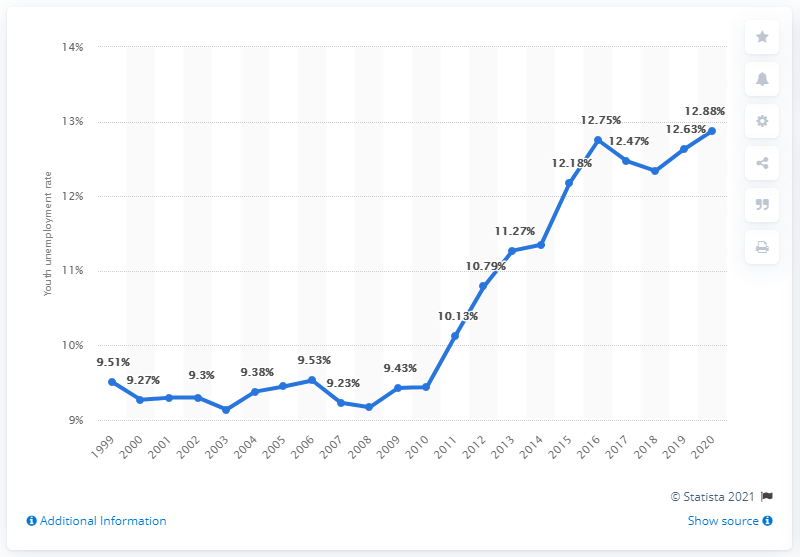Indicate a few pertinent items in this graphic. In 2020, the youth unemployment rate in Timor-Leste was 12.88%. 